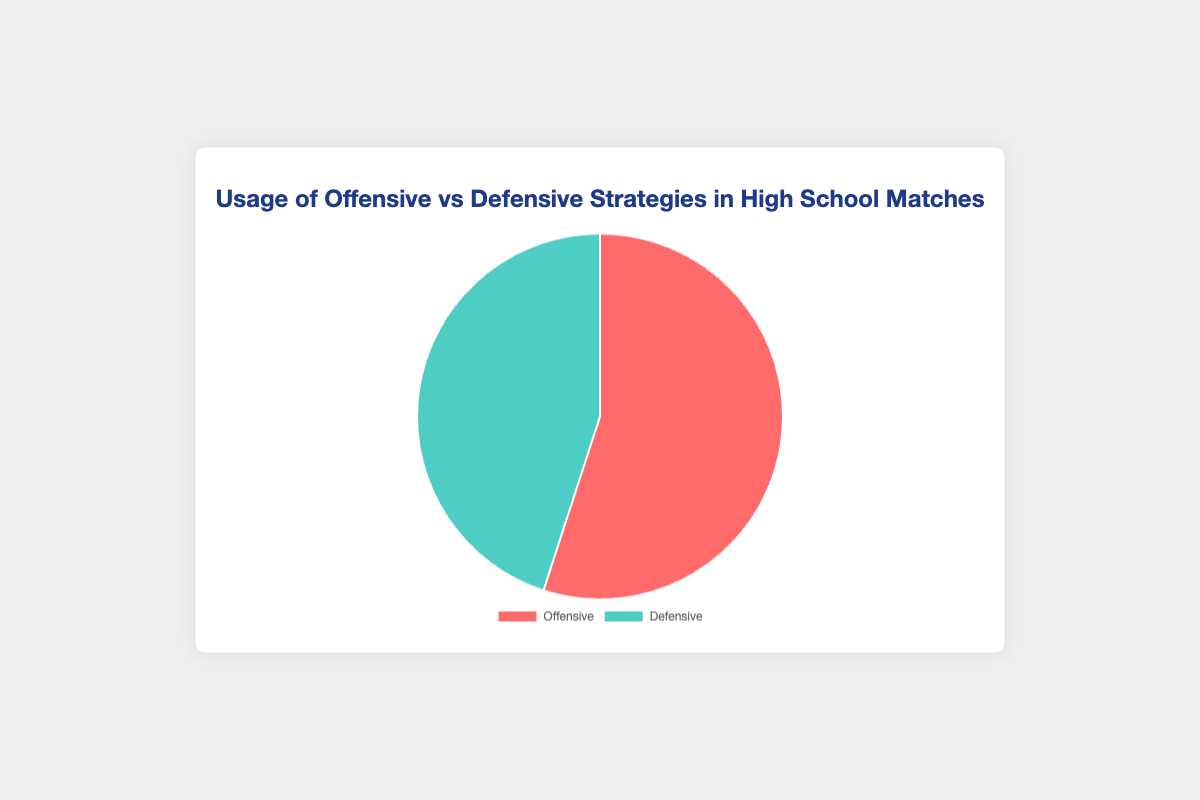What percentage of overall strategy usage is defensive? The pie chart data shows two strategies: offensive (55%) and defensive (45%). The defensive strategy usage is given directly as 45%.
Answer: 45% How much more is the usage of offensive strategies compared to defensive strategies? To find how much more offensive strategy usage is compared to defensive, subtract the defensive percentage from the offensive percentage: 55% - 45% = 10%.
Answer: 10% What is the ratio of offensive to defensive strategies usage? The offensive strategy usage is 55%, and the defensive strategy usage is 45%. To find the ratio, divide 55 by 45, which simplifies to approximately 1.22:1.
Answer: 1.22:1 If the total number of strategies used in matches is 100, how many are offensive strategies? Given that offensive strategies make up 55% of the total strategies and assuming 100 strategies are used, multiply 100 by 0.55: 100 * 0.55 = 55 strategies.
Answer: 55 What is the difference in the number of strategies used if the total usage was 200 matches? To find the difference, calculate the number of offensive strategies (200 * 0.55 = 110) and defensive strategies (200 * 0.45 = 90), then subtract: 110 - 90 = 20.
Answer: 20 Which strategy is more commonly used? By comparing the percentages provided in the pie chart, offensive strategies (55%) are more commonly used than defensive strategies (45%).
Answer: Offensive By what percentage does offensive strategy exceed defensive strategy usage? Calculate the percentage by which offensive strategies exceed defensive strategies: (55% - 45%) = 10%.
Answer: 10% What fraction of the total strategy usage is defensive strategies? The defensive strategy usage is 45%. To convert this to a fraction, it is 45/100, which simplifies to 9/20.
Answer: 9/20 What are the colors representing offensive and defensive strategies? According to the pie chart, offensive strategies are represented by red, and defensive strategies are represented by green.
Answer: Red and Green 